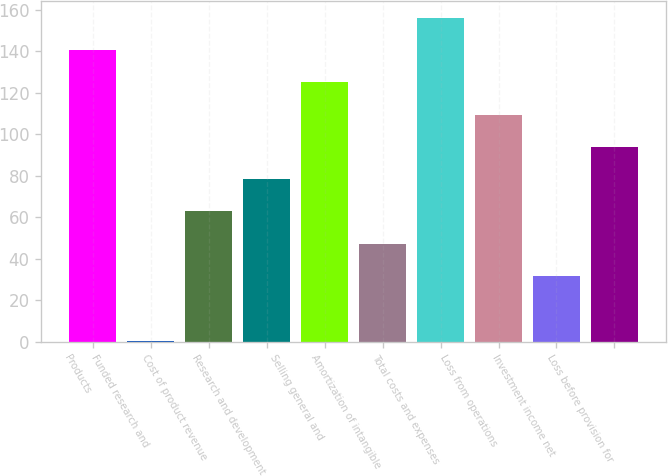<chart> <loc_0><loc_0><loc_500><loc_500><bar_chart><fcel>Products<fcel>Funded research and<fcel>Cost of product revenue<fcel>Research and development<fcel>Selling general and<fcel>Amortization of intangible<fcel>Total costs and expenses<fcel>Loss from operations<fcel>Investment income net<fcel>Loss before provision for<nl><fcel>140.72<fcel>0.5<fcel>62.82<fcel>78.4<fcel>125.14<fcel>47.24<fcel>156.3<fcel>109.56<fcel>31.66<fcel>93.98<nl></chart> 